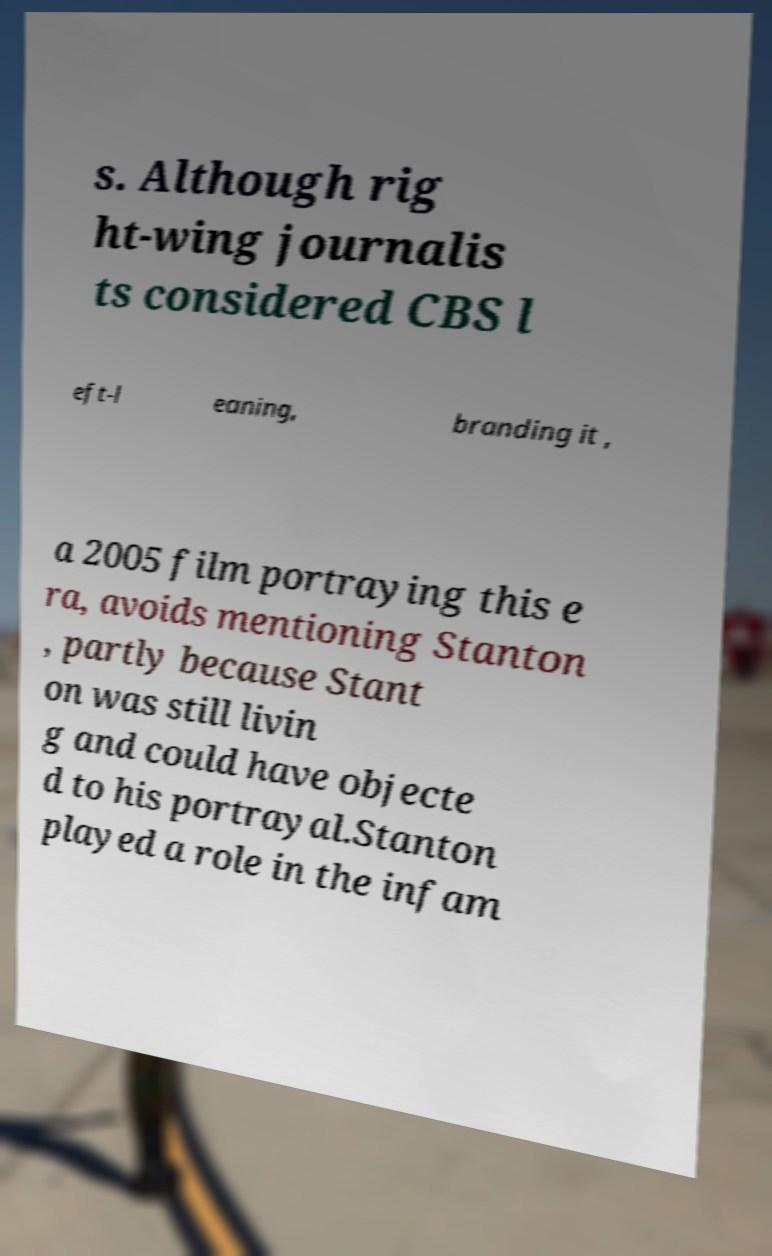For documentation purposes, I need the text within this image transcribed. Could you provide that? s. Although rig ht-wing journalis ts considered CBS l eft-l eaning, branding it , a 2005 film portraying this e ra, avoids mentioning Stanton , partly because Stant on was still livin g and could have objecte d to his portrayal.Stanton played a role in the infam 